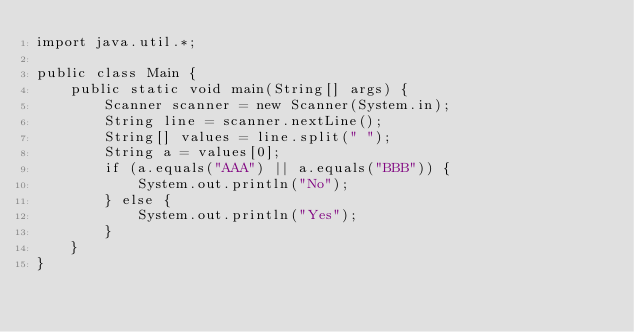Convert code to text. <code><loc_0><loc_0><loc_500><loc_500><_Java_>import java.util.*;

public class Main {
    public static void main(String[] args) {
        Scanner scanner = new Scanner(System.in);
        String line = scanner.nextLine();
        String[] values = line.split(" ");
        String a = values[0];
        if (a.equals("AAA") || a.equals("BBB")) {
            System.out.println("No");
        } else {
            System.out.println("Yes");
        }
    }
}</code> 